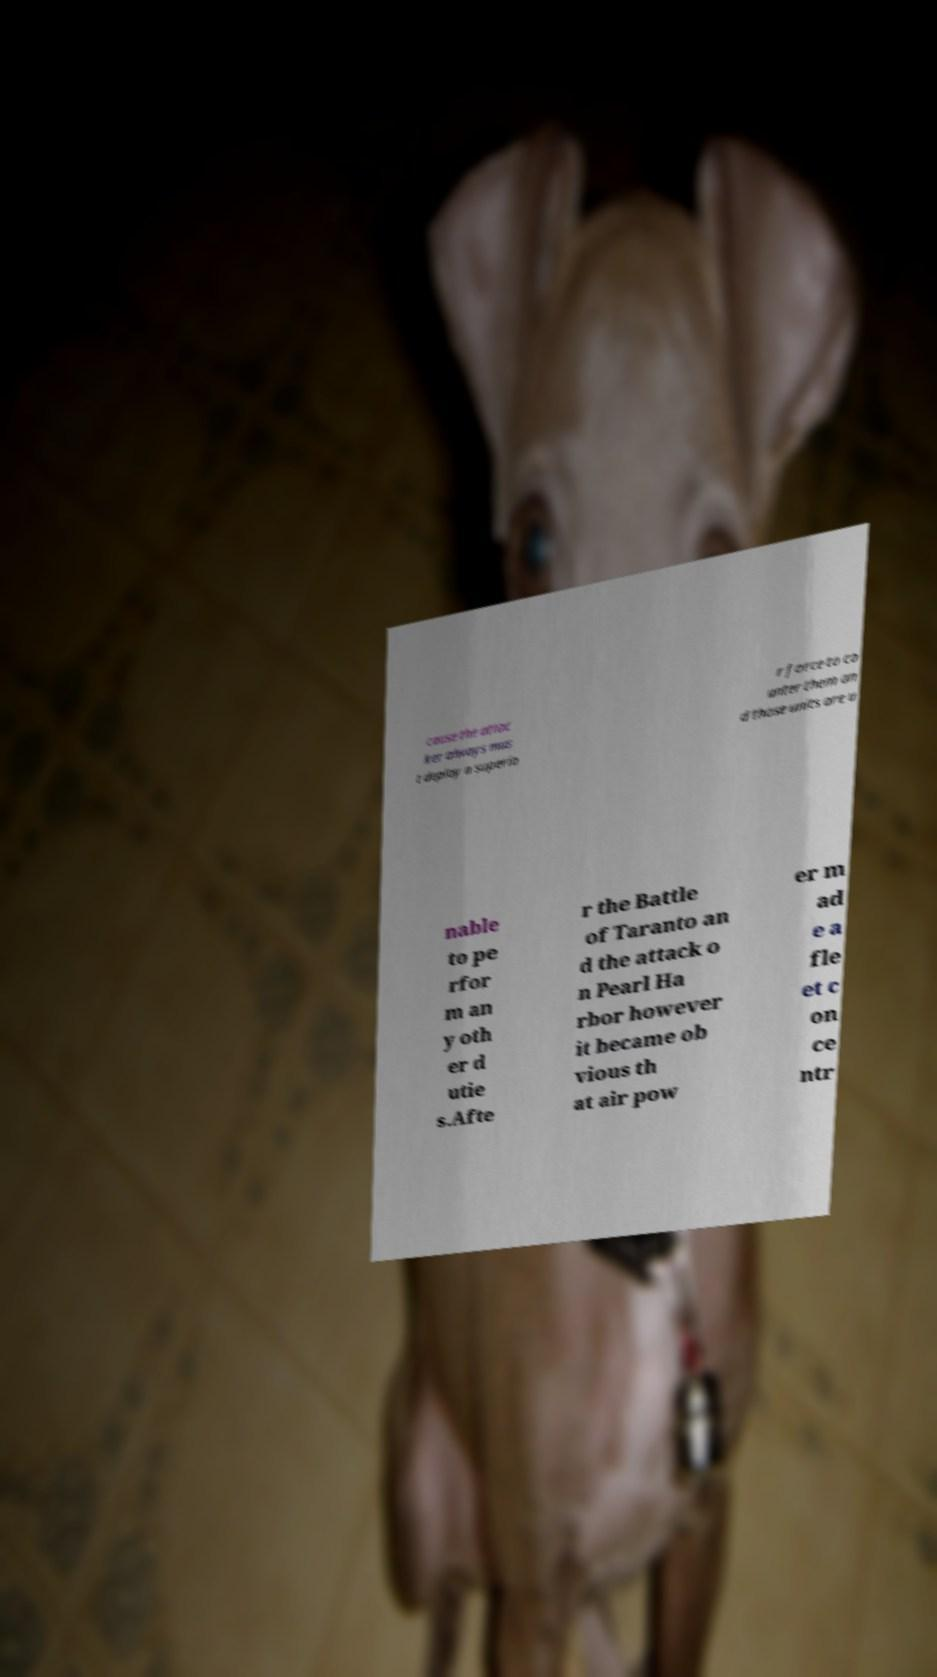Can you accurately transcribe the text from the provided image for me? cause the attac ker always mus t deploy a superio r force to co unter them an d those units are u nable to pe rfor m an y oth er d utie s.Afte r the Battle of Taranto an d the attack o n Pearl Ha rbor however it became ob vious th at air pow er m ad e a fle et c on ce ntr 